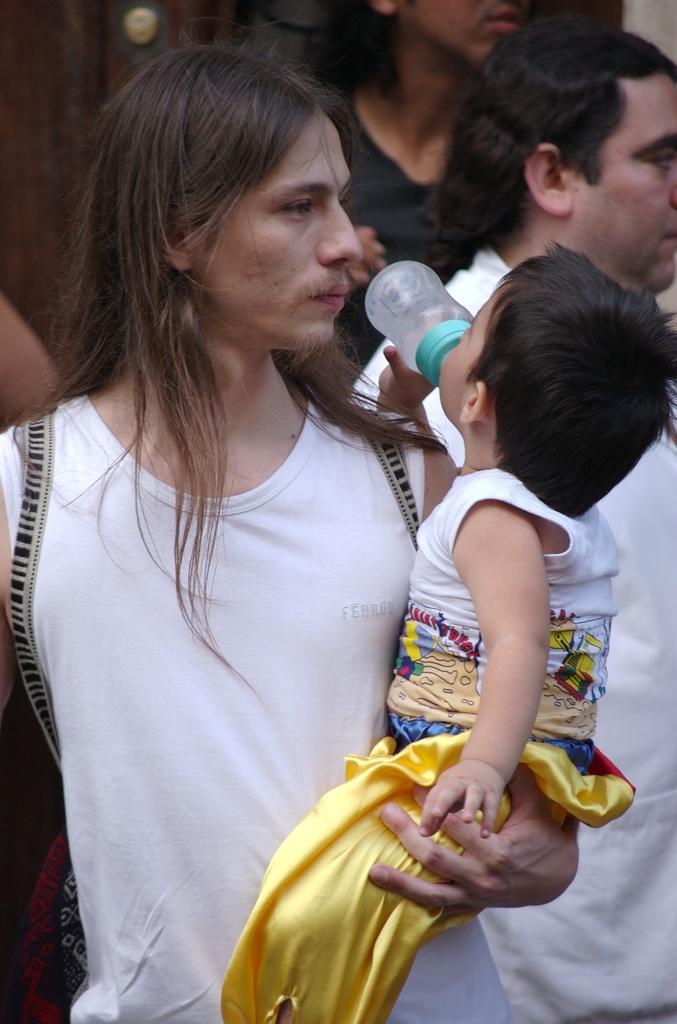Please provide a concise description of this image. In the image there is a man with long hair holding a baby. The baby is consuming milk, and beside of him there are several men and also in background. 